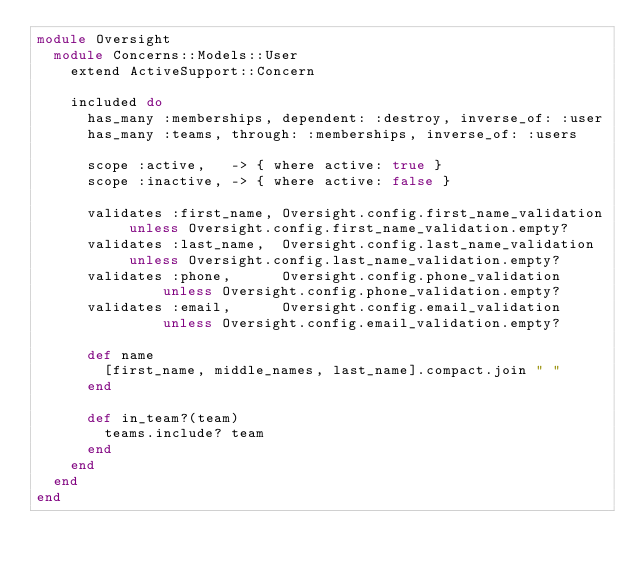Convert code to text. <code><loc_0><loc_0><loc_500><loc_500><_Ruby_>module Oversight
  module Concerns::Models::User
    extend ActiveSupport::Concern

    included do
      has_many :memberships, dependent: :destroy, inverse_of: :user
      has_many :teams, through: :memberships, inverse_of: :users

      scope :active,   -> { where active: true }
      scope :inactive, -> { where active: false }

      validates :first_name, Oversight.config.first_name_validation unless Oversight.config.first_name_validation.empty?
      validates :last_name,  Oversight.config.last_name_validation  unless Oversight.config.last_name_validation.empty?
      validates :phone,      Oversight.config.phone_validation      unless Oversight.config.phone_validation.empty?
      validates :email,      Oversight.config.email_validation      unless Oversight.config.email_validation.empty?

      def name
        [first_name, middle_names, last_name].compact.join " "
      end

      def in_team?(team)
        teams.include? team
      end
    end
  end
end
</code> 